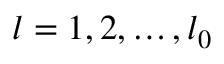<formula> <loc_0><loc_0><loc_500><loc_500>l = 1 , 2 , \dots , l _ { 0 }</formula> 